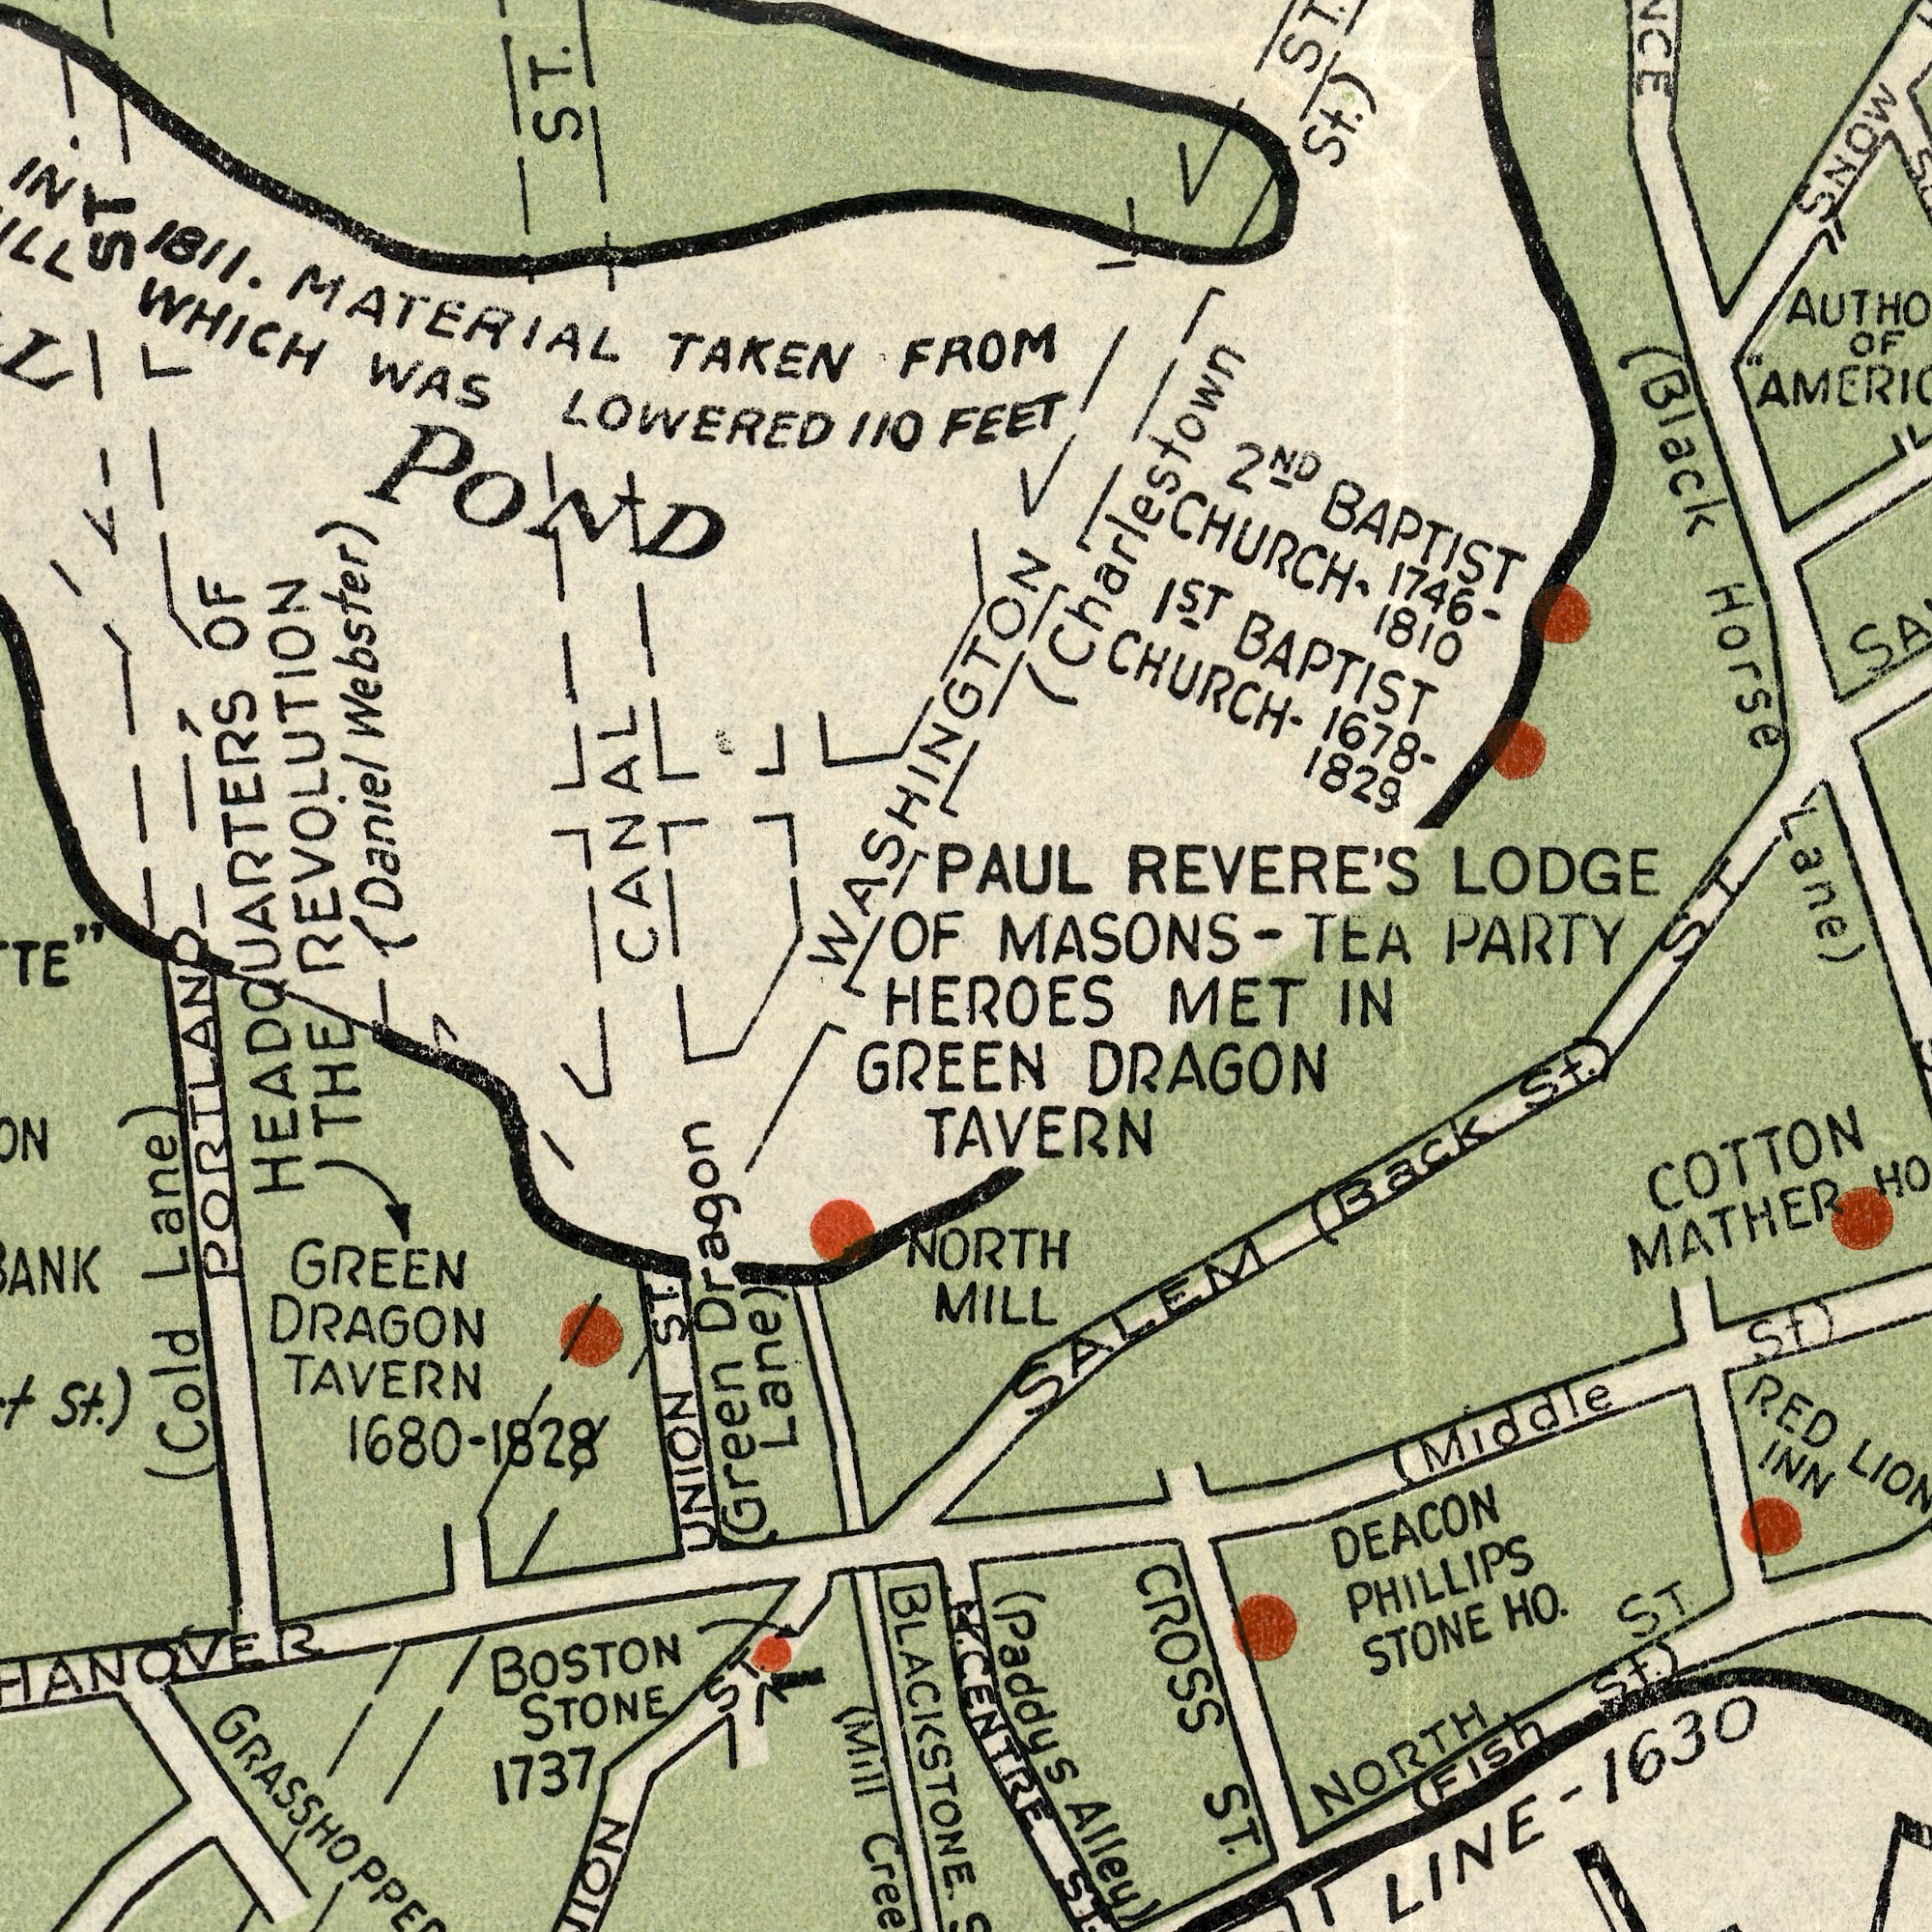What text can you see in the bottom-left section? DRAGON (Mill 1737 BOSTON STONE 1680 Lane) (Cold TAVERN St.) PORTLAND GREEN BLACKSTONE THE UNION ST. Dragon (Green Lane) GREEN ST. ###. -1828 What text is shown in the top-left quadrant? TAKEN WAS OF POND 1811. WHICH MATERIAL CANAL ST. 110 LOWERED HEADQUARTERS ST. FROM OF REVOLUTION (Daniel Webster) WASHINGTON What text appears in the top-right area of the image? BAPTIST BAPTIST MASONS- PARTY LODGE 1<sup>ST</sup> 1829 1810 REVERE'S 1678- (Black TEA 1746- FEET Lane) OF CHURCH- Horse ST. CHURCH- St.) (Charlestown SNOW 2<sup>ND</sup> PAUL ST. What text is shown in the bottom-right quadrant? INN STONE NORTH LINE- PHILLIPS HO. MATHER RED COTTON DEACON ST. ST. Alley) (Back (Paddys (FISH St.) CROSS (Middle ST. St.) SALEM 1630 NORTH HEROES MET IN DRAGON TAVERN MILL CENTRE St.) 